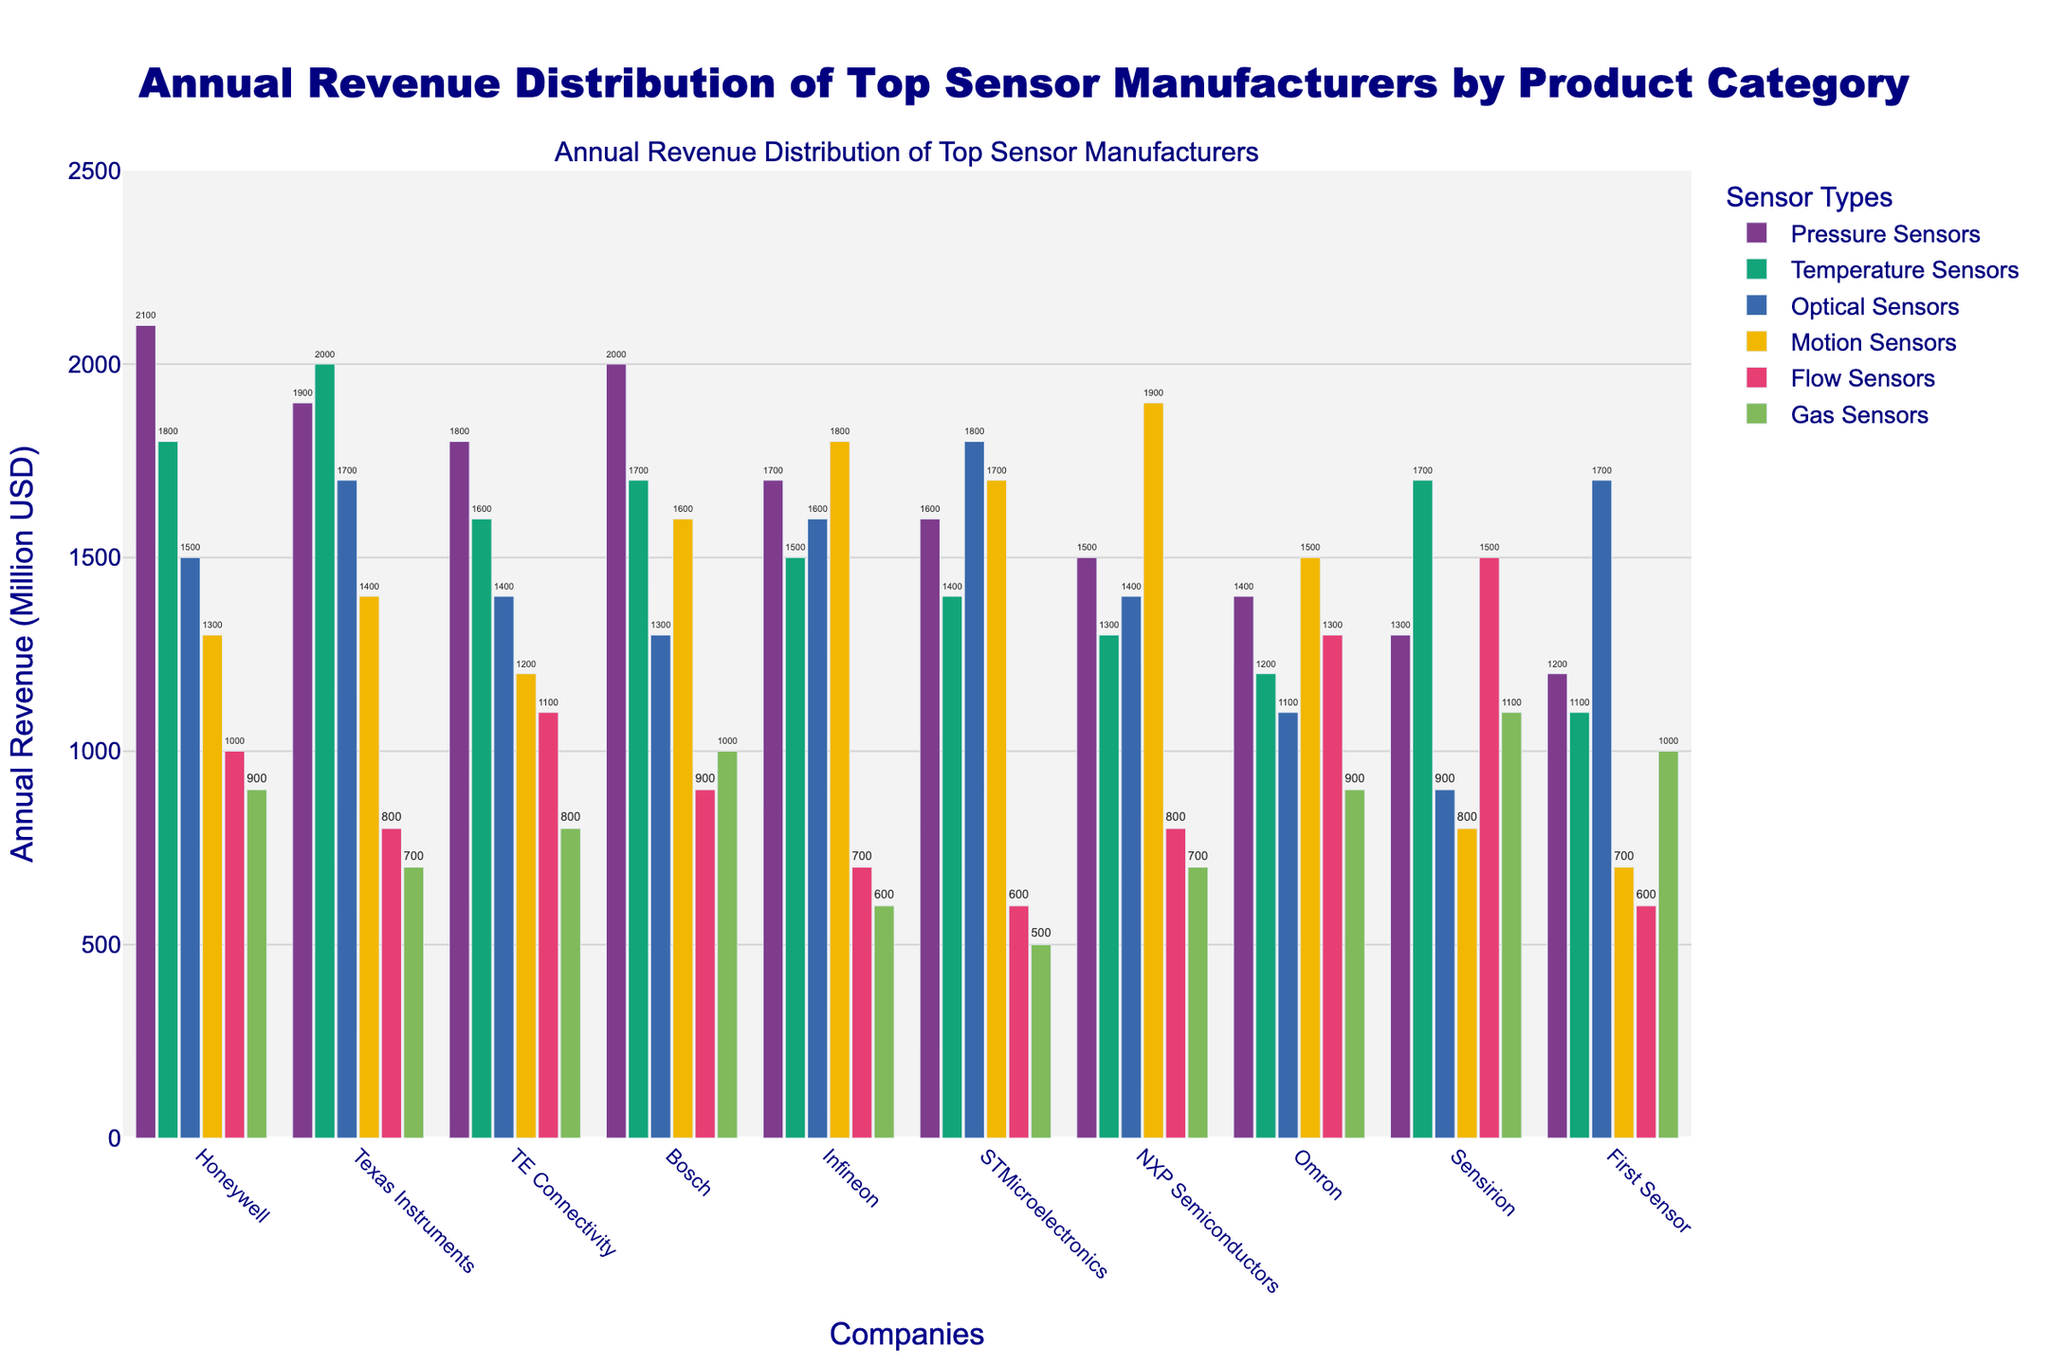Which company has the highest annual revenue in Pressure Sensors? By examining the heights of the bars for Pressure Sensors, Honeywell has the highest bar which corresponds to an annual revenue of 2100 (Million USD)
Answer: Honeywell Which sensor type does NXP Semiconductors generate the most revenue from? By observing the heights of the bars for NXP Semiconductors, the bar for Motion Sensors is the tallest, corresponding to a revenue of 1900 (Million USD)
Answer: Motion Sensors What is the total annual revenue from Optical Sensors for Honeywell and Bosch combined? Honeywell has an annual revenue of 1500 (Million USD) from Optical Sensors, and Bosch has an annual revenue of 1300 (Million USD). Summing these values gives 1500 + 1300
Answer: 2800 Which company's revenue from Temperature Sensors is equal to its revenue from Motion Sensors? By observing the heights of the bars, Texas Instruments has equal heights for Temperature Sensors and Motion Sensors, both at 2000 and 1400 (Million USD) respectively
Answer: Texas Instruments Between STMicroelectronics and Sensirion, who has the higher average revenue across all sensor categories? Calculate the total revenue for each company first. STMicroelectronics: 1600+1400+1800+1700+600+500 = 7600; Sensirion: 1300+1700+900+800+1500+1100 = 7300. Then calculate the average: STMicroelectronics: 7600/6 = 1266.67, Sensirion: 7300/6 = 1216.67
Answer: STMicroelectronics Which company has the lowest revenue in Gas Sensors? By examining the heights of the bars for Gas Sensors, STMicroelectronics has the shortest bar corresponding to 500 (Million USD)
Answer: STMicroelectronics How does the revenue of Omron for Flow Sensors compare to its revenue from Pressure Sensors? Omron's Flow Sensors revenue is 1300 (Million USD) and Pressure Sensors revenue is 1400 (Million USD). Comparing these, Flow Sensors revenue is less by 100 (Million USD)
Answer: Flow Sensors revenue is less by 100 (Million USD) Compare the revenue from Temperature Sensors for Honeywell and Infineon. How much more or less is Honeywell's revenue compared to Infineon's? Honeywell's revenue from Temperature Sensors is 1800 (Million USD) and Infineon's is 1500 (Million USD). Subtracting Infineon's from Honeywell's, 1800 - 1500 = 300
Answer: 300 more Which product category shows the widest spread in revenues across all companies? By comparing the range (difference between highest and lowest values) for each product category, Motion Sensors: 1900 - 700 = 1200; Temperature Sensors: 2000 - 1100 = 900; and so on. Motion Sensors show the widest spread
Answer: Motion Sensors Across all companies, what is the combined revenue from Gas Sensors? Adding the Gas Sensors revenue for all companies: 900+700+800+1000+600+500+700+900+1100+1000 = 8200 (Million USD)
Answer: 8200 